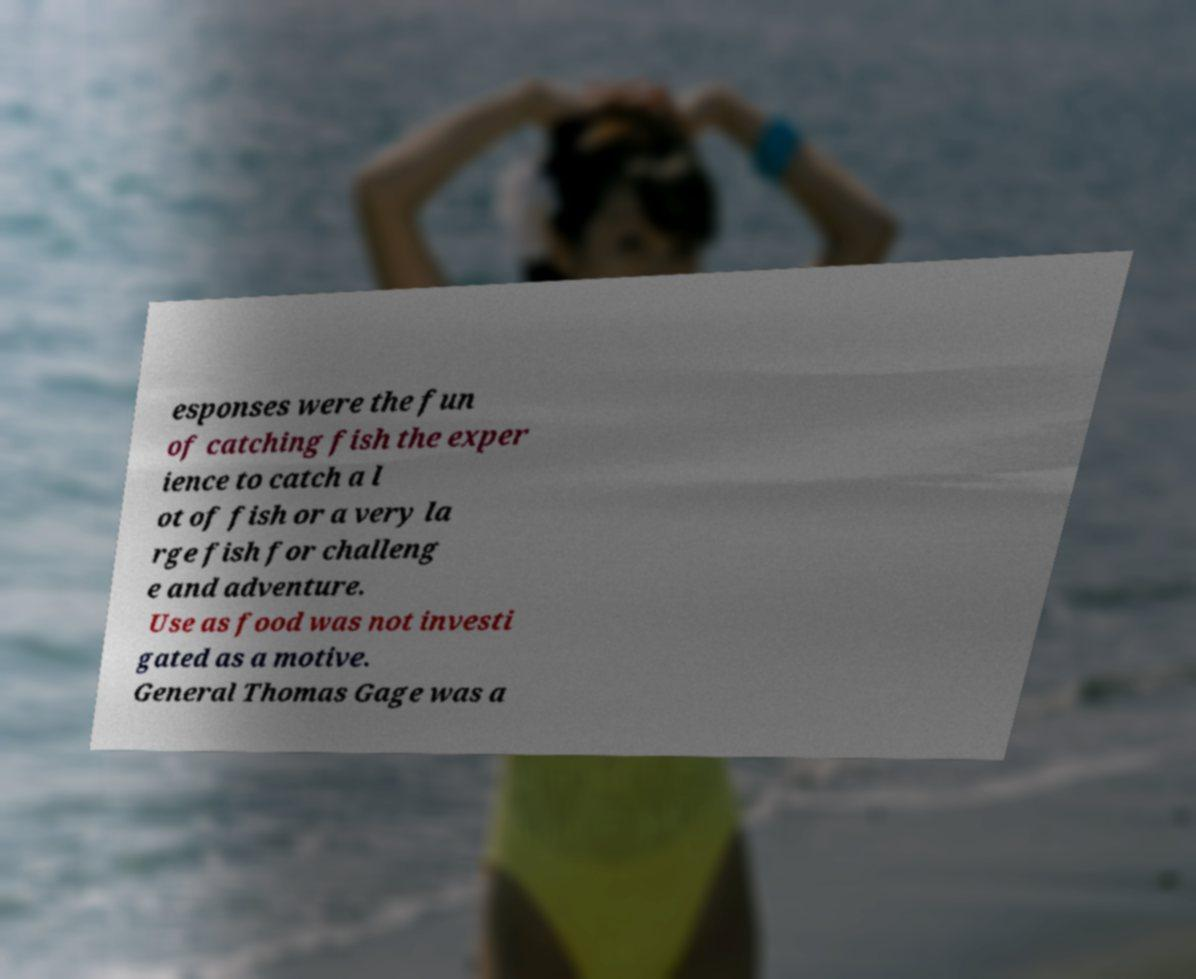Could you assist in decoding the text presented in this image and type it out clearly? esponses were the fun of catching fish the exper ience to catch a l ot of fish or a very la rge fish for challeng e and adventure. Use as food was not investi gated as a motive. General Thomas Gage was a 